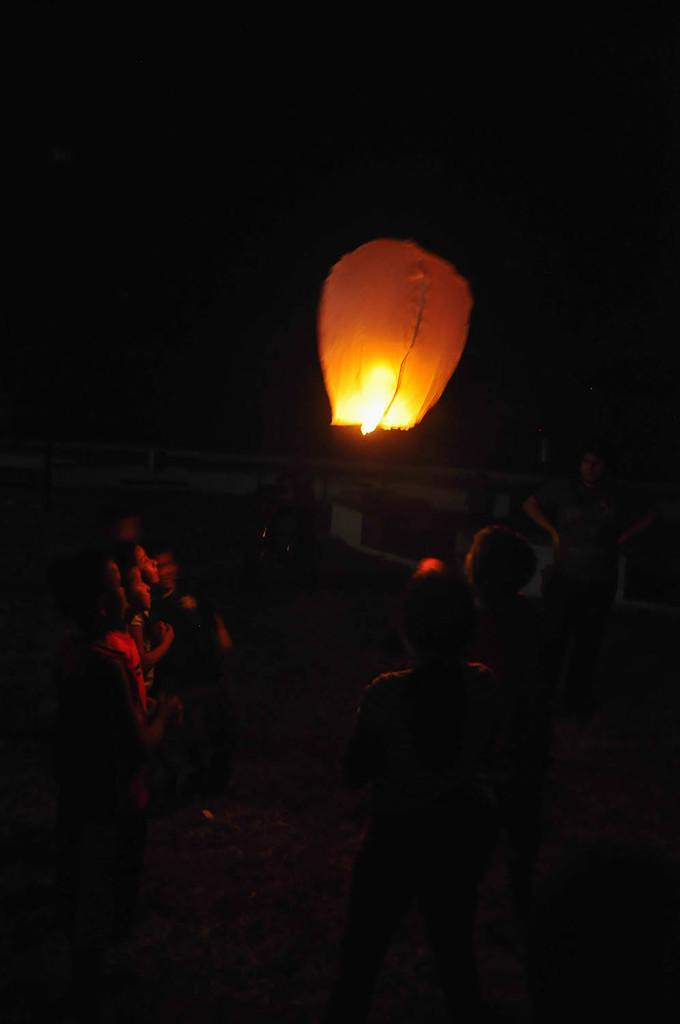Who or what can be seen in the image? There are people in the image. What is the color of the background in the image? The background of the image is black. What is the object floating in the air in the image? There is a sky-lantern visible in the air. How many maids are present in the image? There is no mention of maids in the image, so it is not possible to determine their presence or number. 